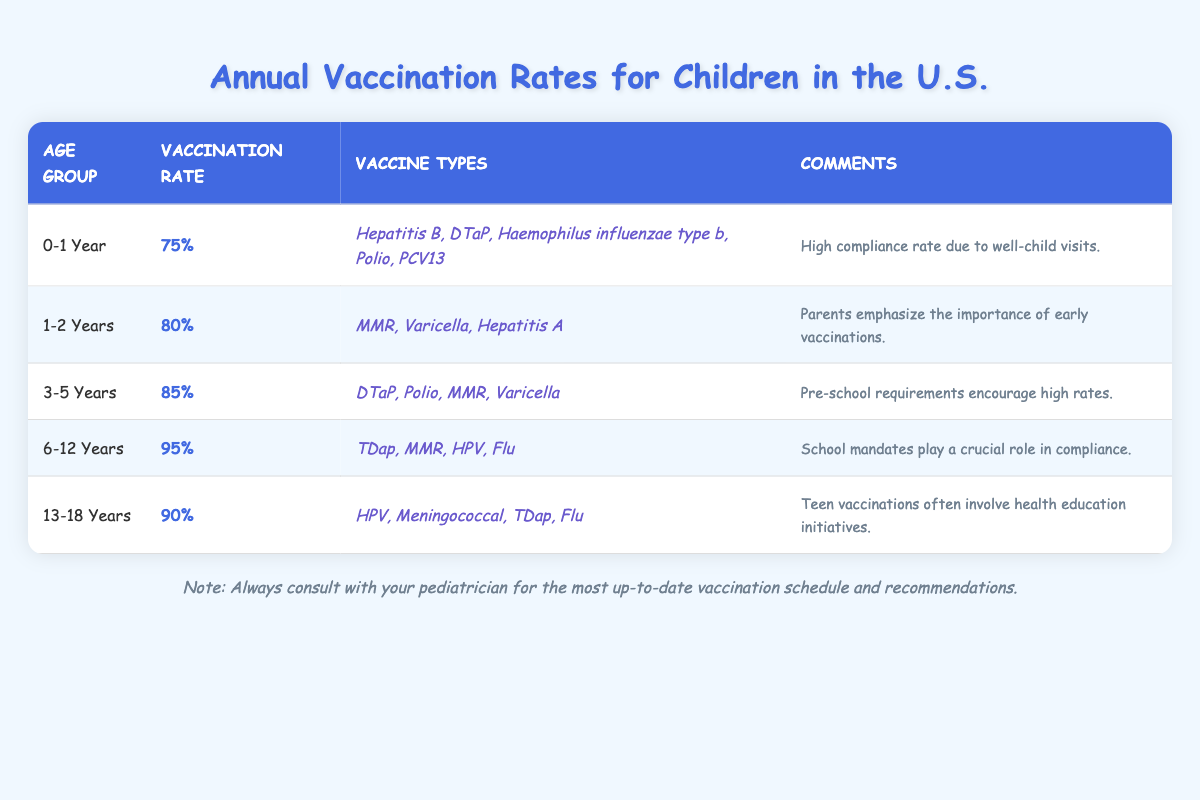What is the vaccination rate for children aged 0-1 year? From the table, we can directly see that the vaccination rate for the age group 0-1 year is listed as 75%.
Answer: 75% Which age group has the highest vaccination rate? By examining the vaccination rates for all age groups in the table, the age group 6-12 years has the highest vaccination rate at 95%.
Answer: 6-12 Years What are the vaccine types administered to 3-5 year olds? Looking at the row for the age group 3-5 years in the table, the vaccine types listed are DTaP, Polio, MMR, and Varicella.
Answer: DTaP, Polio, MMR, Varicella Is the vaccination rate for 13-18 year olds higher than for 1-2 year olds? Comparing the vaccination rates, 13-18 year olds have a rate of 90% and 1-2 year olds have a rate of 80%. Since 90% is greater than 80%, the statement is true.
Answer: Yes What is the average vaccination rate for all age groups? To find the average, sum the vaccination rates (75 + 80 + 85 + 95 + 90) = 425 and then divide by the number of age groups (5). Thus, 425/5 = 85.
Answer: 85% What is the difference in vaccination rates between the 6-12 year age group and the 1-2 year age group? The vaccination rate for 6-12 years is 95% and for 1-2 years is 80%. The difference is calculated as 95% - 80% = 15%.
Answer: 15% Are the comments associated with the vaccination rates mostly positive about compliance? Examining the comments for each age group, they all indicate positive insights about compliance, such as high compliance due to visits and school mandates.
Answer: Yes Which vaccines are given to children aged 6-12 years? Referring to the table, the vaccines listed for the 6-12 years age group include TDap, MMR, HPV, and Flu.
Answer: TDap, MMR, HPV, Flu What trends do you notice about vaccination rates as age increases? Observing the table, vaccination rates appear to increase with age, from 75% in the youngest group to 95% in the 6-12 year group.
Answer: Increasing trend How many vaccine types are administered to children aged 1-2 years? The table shows that 3 vaccine types (MMR, Varicella, and Hepatitis A) are listed for the 1-2 years age group. Thus, the count is three.
Answer: 3 